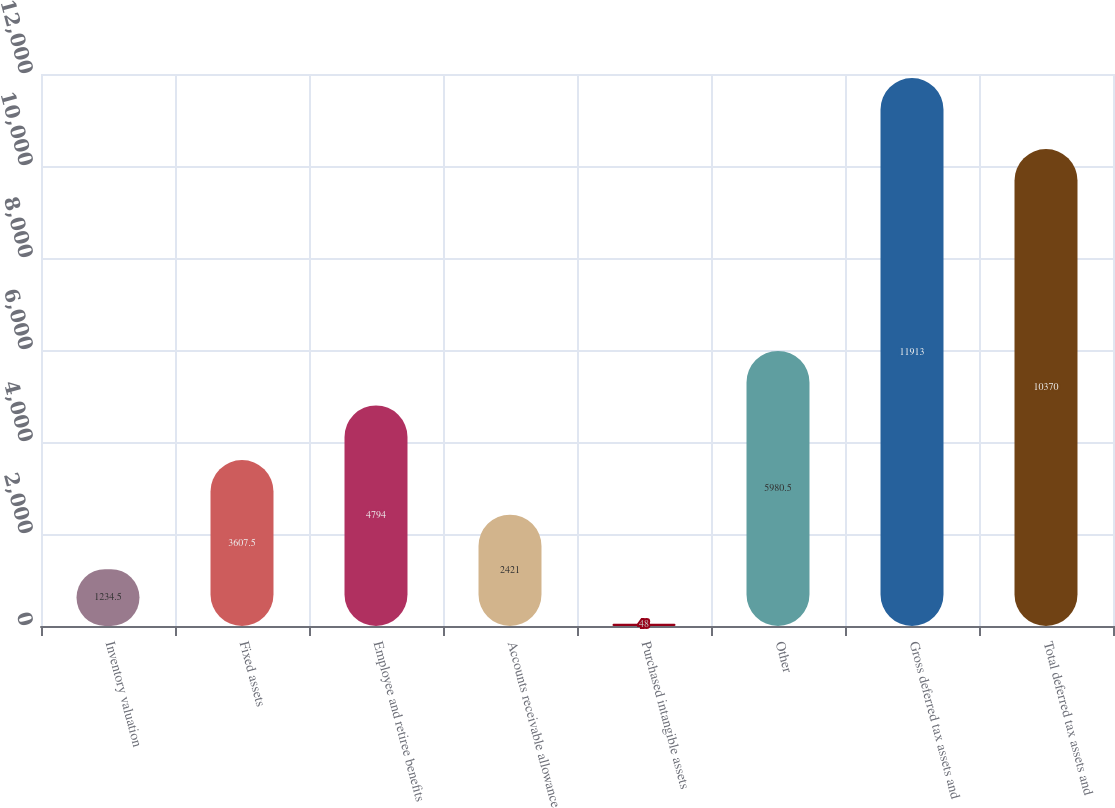Convert chart to OTSL. <chart><loc_0><loc_0><loc_500><loc_500><bar_chart><fcel>Inventory valuation<fcel>Fixed assets<fcel>Employee and retiree benefits<fcel>Accounts receivable allowance<fcel>Purchased intangible assets<fcel>Other<fcel>Gross deferred tax assets and<fcel>Total deferred tax assets and<nl><fcel>1234.5<fcel>3607.5<fcel>4794<fcel>2421<fcel>48<fcel>5980.5<fcel>11913<fcel>10370<nl></chart> 